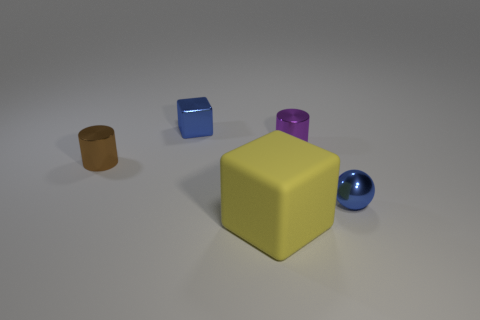There is a block that is in front of the tiny brown object; what material is it?
Offer a very short reply. Rubber. How many objects are either yellow objects or small things to the left of the rubber object?
Your answer should be very brief. 3. There is a purple thing that is the same size as the brown cylinder; what shape is it?
Your answer should be compact. Cylinder. How many metallic balls are the same color as the big cube?
Your answer should be compact. 0. Is the block in front of the small metal ball made of the same material as the tiny brown thing?
Your response must be concise. No. What is the shape of the yellow object?
Your answer should be compact. Cube. What number of gray things are either small metal spheres or small cylinders?
Provide a short and direct response. 0. How many other objects are there of the same material as the tiny brown object?
Keep it short and to the point. 3. Does the blue metallic object on the right side of the small blue cube have the same shape as the yellow rubber thing?
Provide a short and direct response. No. Are any tiny cyan matte objects visible?
Provide a succinct answer. No. 